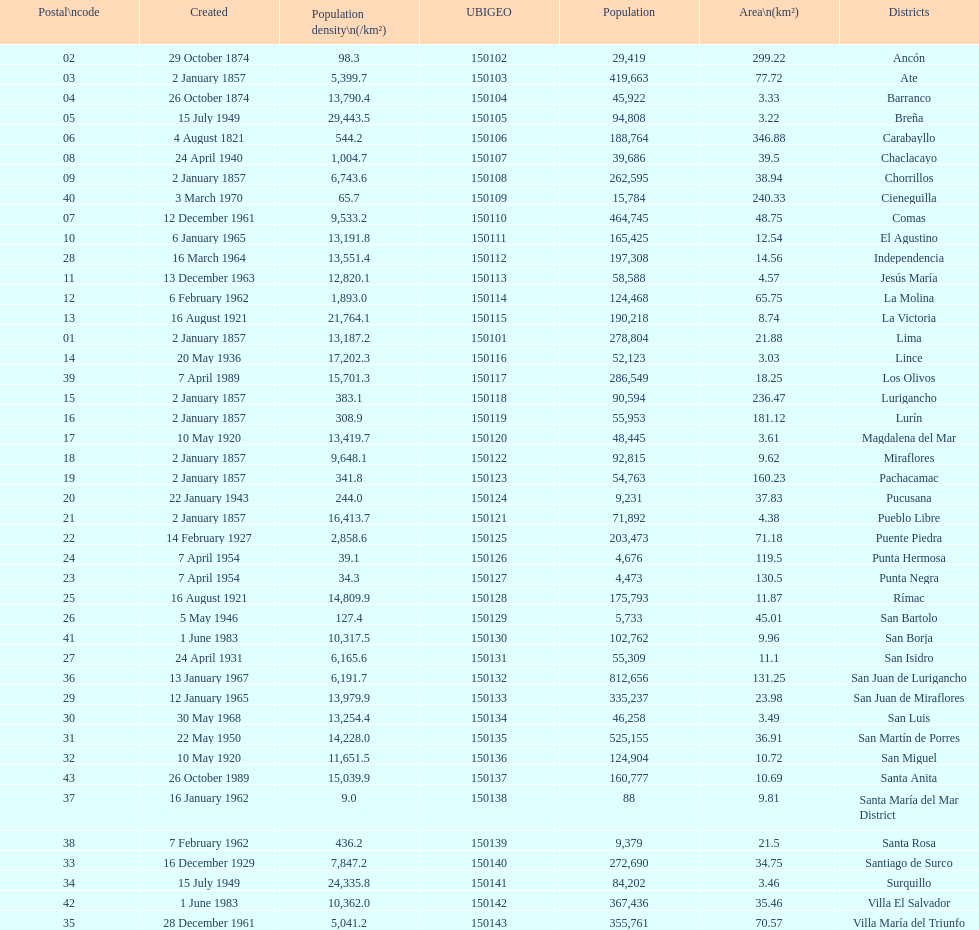How many districts have a population density of at lest 1000.0? 31. 